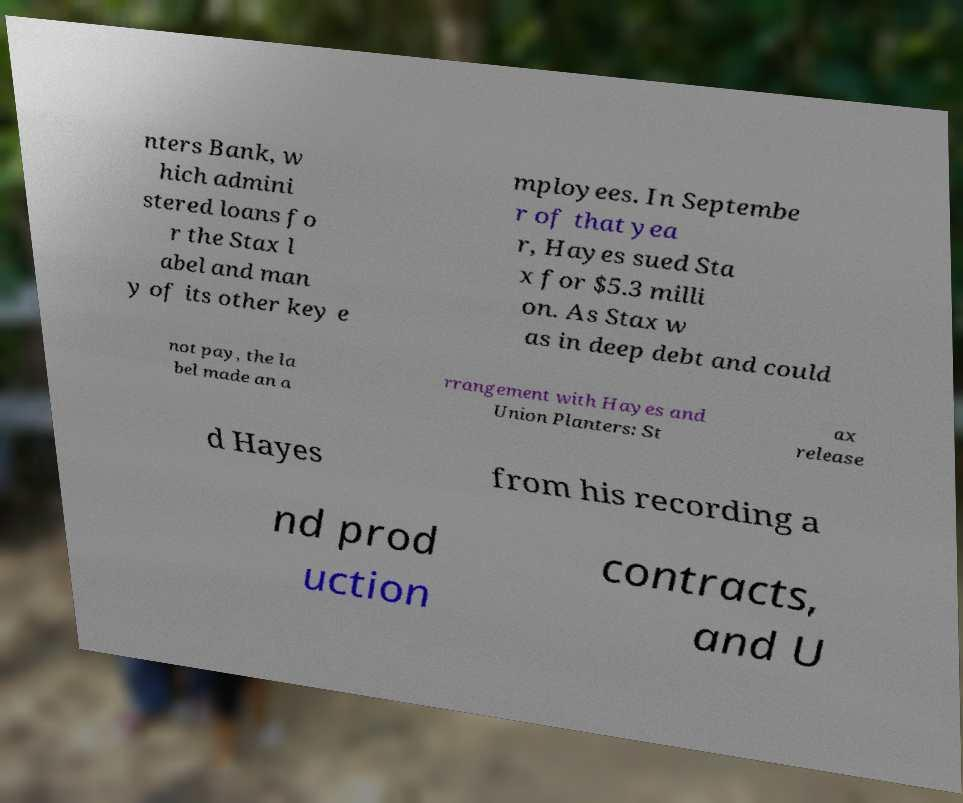What messages or text are displayed in this image? I need them in a readable, typed format. nters Bank, w hich admini stered loans fo r the Stax l abel and man y of its other key e mployees. In Septembe r of that yea r, Hayes sued Sta x for $5.3 milli on. As Stax w as in deep debt and could not pay, the la bel made an a rrangement with Hayes and Union Planters: St ax release d Hayes from his recording a nd prod uction contracts, and U 